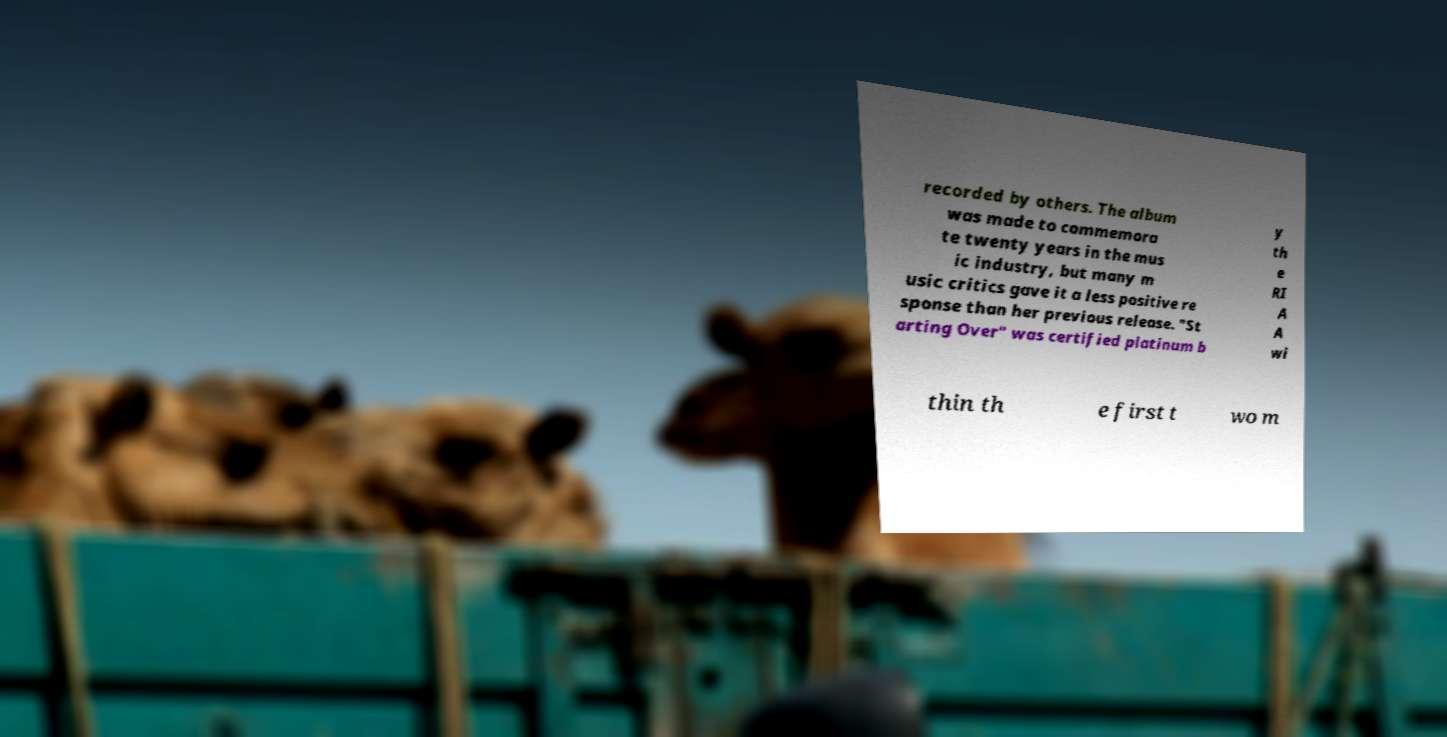For documentation purposes, I need the text within this image transcribed. Could you provide that? recorded by others. The album was made to commemora te twenty years in the mus ic industry, but many m usic critics gave it a less positive re sponse than her previous release. "St arting Over" was certified platinum b y th e RI A A wi thin th e first t wo m 